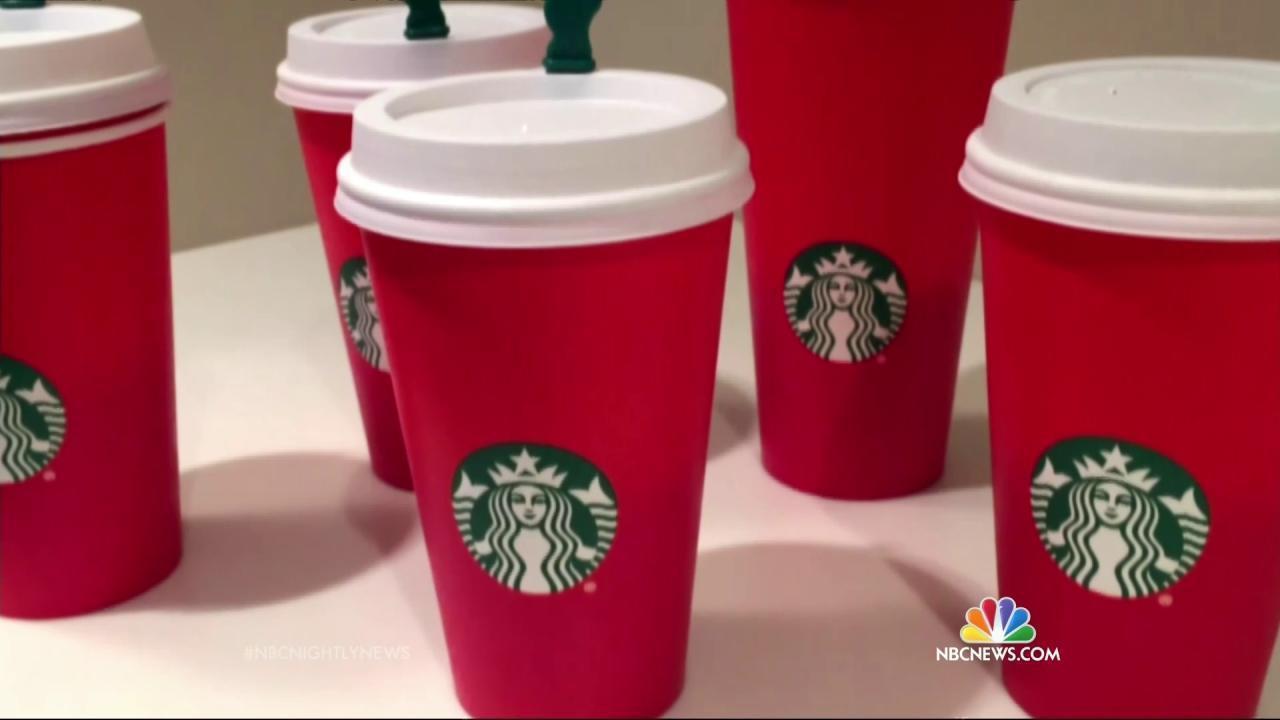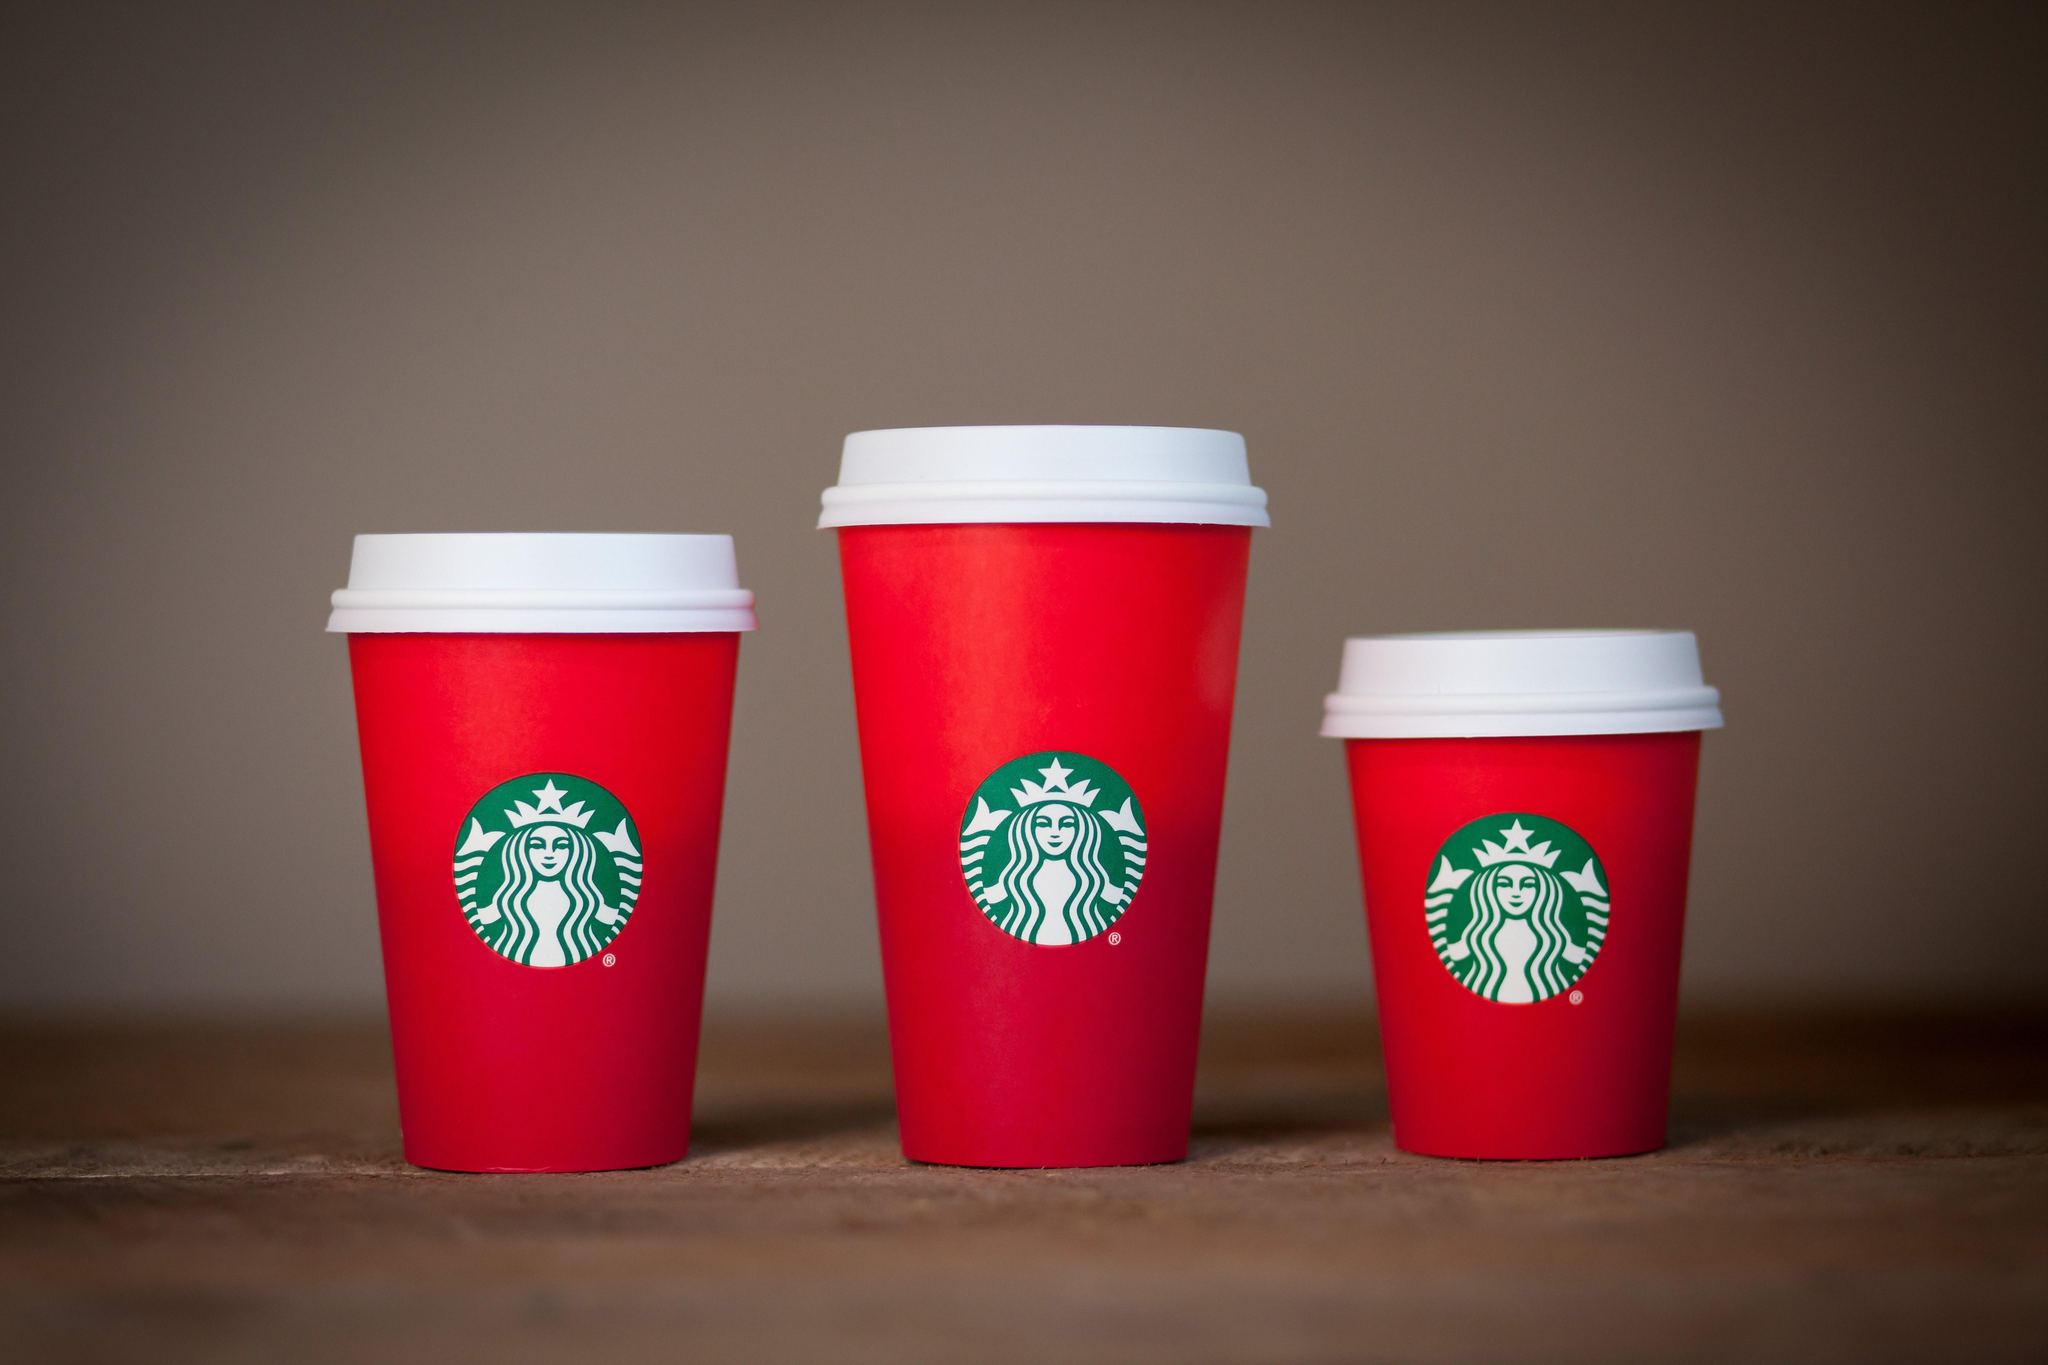The first image is the image on the left, the second image is the image on the right. For the images displayed, is the sentence "There are two cups total." factually correct? Answer yes or no. No. The first image is the image on the left, the second image is the image on the right. Analyze the images presented: Is the assertion "There is a total of two red coffee cups." valid? Answer yes or no. No. 